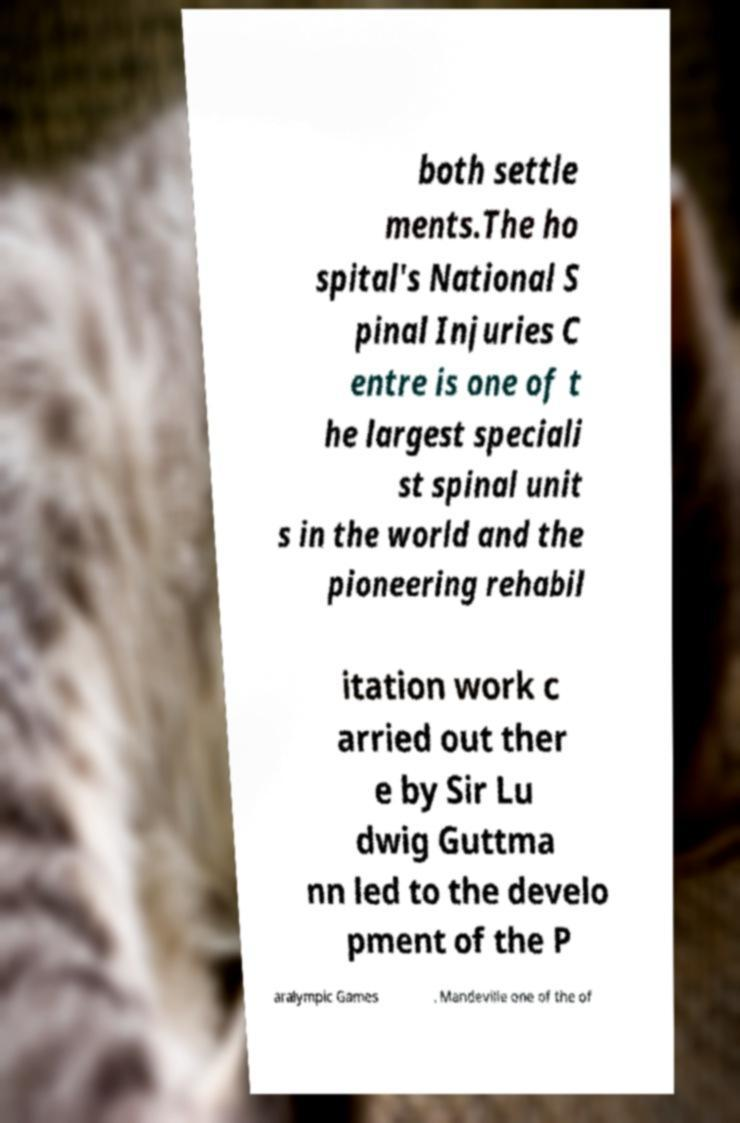I need the written content from this picture converted into text. Can you do that? both settle ments.The ho spital's National S pinal Injuries C entre is one of t he largest speciali st spinal unit s in the world and the pioneering rehabil itation work c arried out ther e by Sir Lu dwig Guttma nn led to the develo pment of the P aralympic Games . Mandeville one of the of 